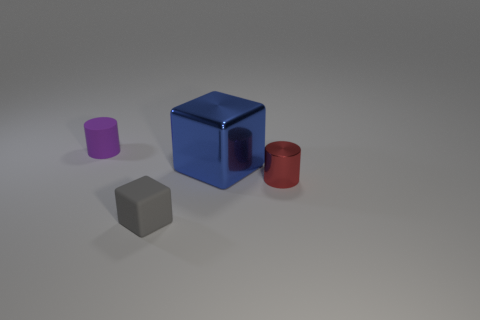Add 3 big brown cylinders. How many objects exist? 7 Add 1 big metallic objects. How many big metallic objects are left? 2 Add 3 blue things. How many blue things exist? 4 Subtract 0 blue balls. How many objects are left? 4 Subtract all small metal balls. Subtract all red metallic cylinders. How many objects are left? 3 